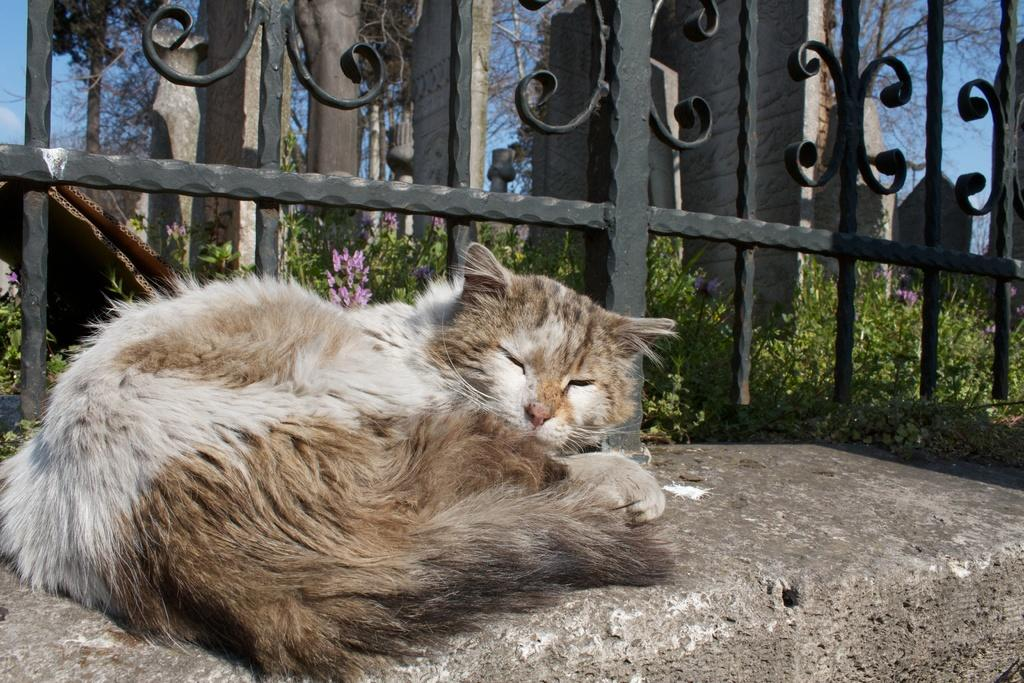What type of animal is in the image? There is a cat in the image. Where is the cat located? The cat is on a stone. What can be seen in the background of the image? There are trees and the sky visible in the background of the image. What type of vegetation is present in the image? There are plants with flowers in the image. What else can be seen in the image besides the cat and plants? There is a fence and other objects in the image. What type of dinner is being served in the image? There is no dinner present in the image; it features a cat on a stone with a fence, plants, trees, and other objects. What error can be corrected in the image? There is no error present in the image; it accurately depicts a cat on a stone with a fence, plants, trees, and other objects. 